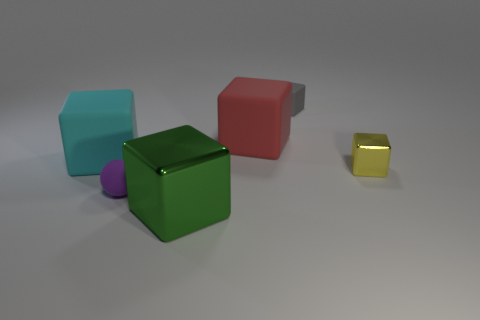How many things are either big matte balls or small rubber things?
Offer a terse response. 2. What shape is the tiny object to the right of the small cube that is behind the cyan rubber block?
Your answer should be compact. Cube. How many other things are made of the same material as the large green cube?
Your answer should be compact. 1. Is the cyan object made of the same material as the small block that is behind the small yellow object?
Keep it short and to the point. Yes. What number of objects are either big things on the right side of the tiny ball or rubber blocks that are in front of the red cube?
Make the answer very short. 3. What number of other objects are there of the same color as the tiny matte block?
Offer a very short reply. 0. Are there more gray matte things in front of the cyan cube than large cyan cubes that are to the right of the gray rubber block?
Make the answer very short. No. Is there anything else that is the same size as the green shiny cube?
Provide a short and direct response. Yes. How many cylinders are tiny yellow things or big green shiny things?
Your answer should be very brief. 0. How many things are either tiny blocks in front of the big red block or yellow matte spheres?
Offer a very short reply. 1. 